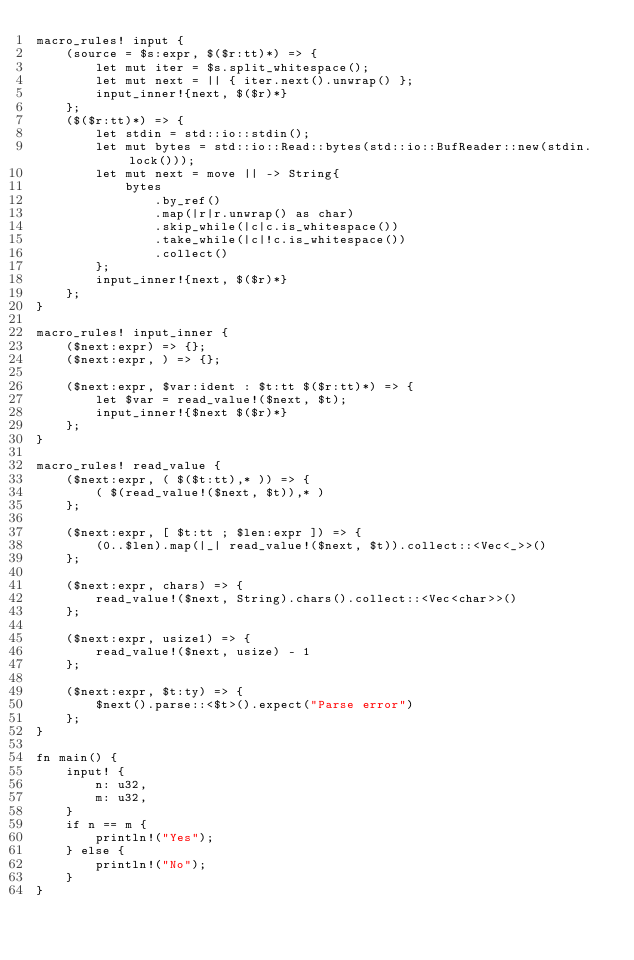Convert code to text. <code><loc_0><loc_0><loc_500><loc_500><_Rust_>macro_rules! input {
    (source = $s:expr, $($r:tt)*) => {
        let mut iter = $s.split_whitespace();
        let mut next = || { iter.next().unwrap() };
        input_inner!{next, $($r)*}
    };
    ($($r:tt)*) => {
        let stdin = std::io::stdin();
        let mut bytes = std::io::Read::bytes(std::io::BufReader::new(stdin.lock()));
        let mut next = move || -> String{
            bytes
                .by_ref()
                .map(|r|r.unwrap() as char)
                .skip_while(|c|c.is_whitespace())
                .take_while(|c|!c.is_whitespace())
                .collect()
        };
        input_inner!{next, $($r)*}
    };
}
 
macro_rules! input_inner {
    ($next:expr) => {};
    ($next:expr, ) => {};
 
    ($next:expr, $var:ident : $t:tt $($r:tt)*) => {
        let $var = read_value!($next, $t);
        input_inner!{$next $($r)*}
    };
}
 
macro_rules! read_value {
    ($next:expr, ( $($t:tt),* )) => {
        ( $(read_value!($next, $t)),* )
    };
 
    ($next:expr, [ $t:tt ; $len:expr ]) => {
        (0..$len).map(|_| read_value!($next, $t)).collect::<Vec<_>>()
    };
 
    ($next:expr, chars) => {
        read_value!($next, String).chars().collect::<Vec<char>>()
    };
 
    ($next:expr, usize1) => {
        read_value!($next, usize) - 1
    };
 
    ($next:expr, $t:ty) => {
        $next().parse::<$t>().expect("Parse error")
    };
}

fn main() {
    input! {
        n: u32,
        m: u32,
    }
    if n == m {
        println!("Yes");
    } else {
        println!("No");
    }
}
</code> 